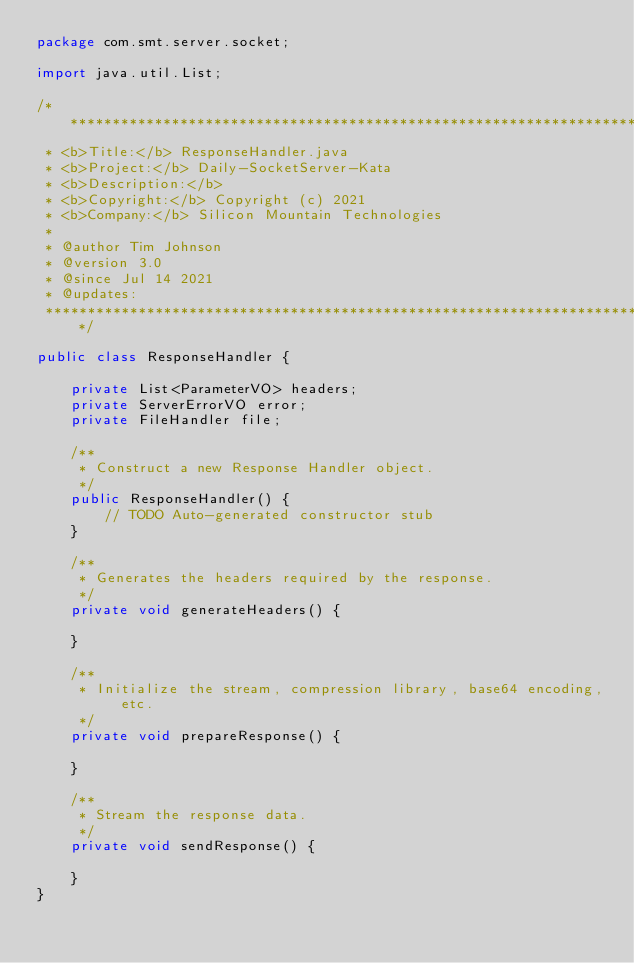<code> <loc_0><loc_0><loc_500><loc_500><_Java_>package com.smt.server.socket;

import java.util.List;

/****************************************************************************
 * <b>Title:</b> ResponseHandler.java
 * <b>Project:</b> Daily-SocketServer-Kata
 * <b>Description:</b> 
 * <b>Copyright:</b> Copyright (c) 2021
 * <b>Company:</b> Silicon Mountain Technologies
 * 
 * @author Tim Johnson
 * @version 3.0
 * @since Jul 14 2021
 * @updates:
 ****************************************************************************/

public class ResponseHandler {
	
    private List<ParameterVO> headers;
    private ServerErrorVO error;
    private FileHandler file;

	/**
	 * Construct a new Response Handler object.
	 */
	public ResponseHandler() {
		// TODO Auto-generated constructor stub
	}

	/**
	 * Generates the headers required by the response.
	 */
	private void generateHeaders() {
		
	}
	
	/**
	 * Initialize the stream, compression library, base64 encoding, etc.
	 */
	private void prepareResponse() {
		
	}
	
	/**
	 * Stream the response data.
	 */
	private void sendResponse() {
		
	}
}
</code> 